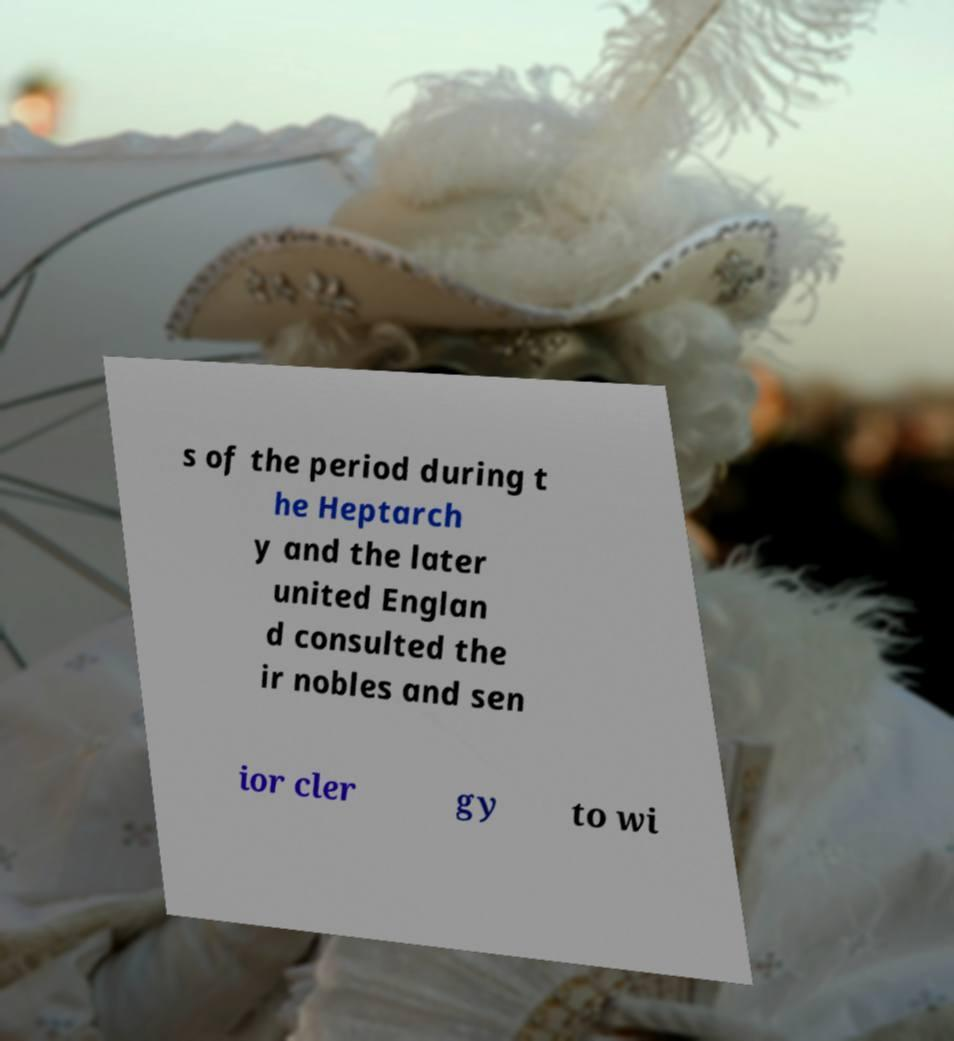I need the written content from this picture converted into text. Can you do that? s of the period during t he Heptarch y and the later united Englan d consulted the ir nobles and sen ior cler gy to wi 